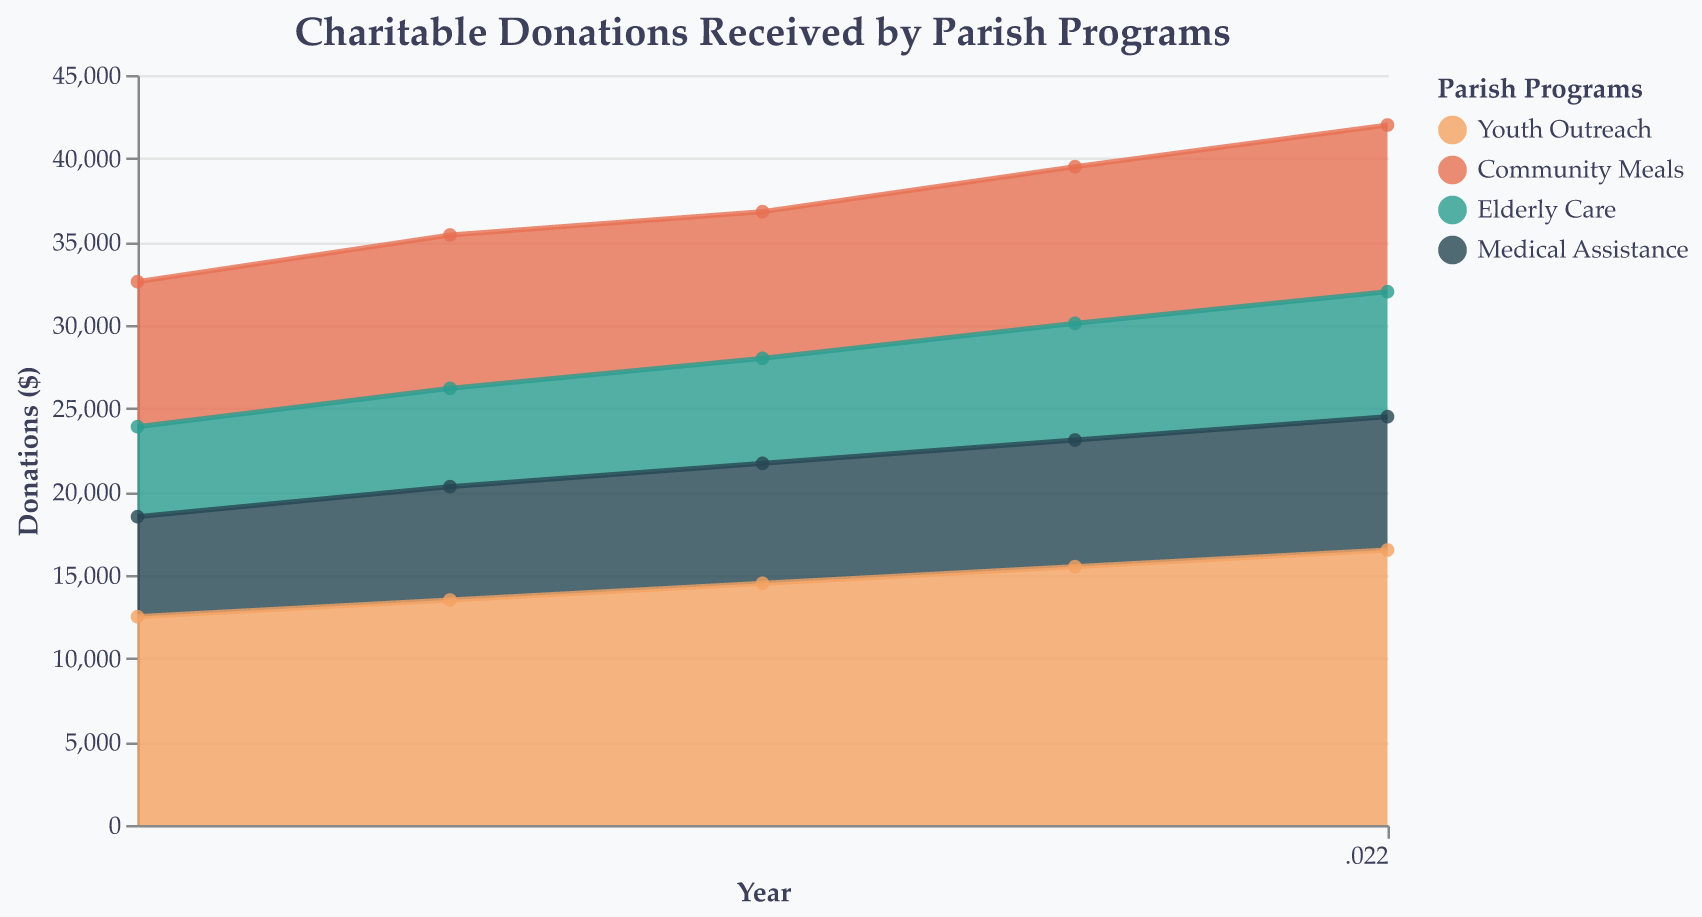What is the title of the chart? The title of the chart is located at the top and usually describes the content or purpose of the figure. In this case, the title is displayed prominently at the top.
Answer: Charitable Donations Received by Parish Programs How many parish programs are tracked in the figure? The legend on the right side of the chart shows the different parish programs tracked.
Answer: Four Which program received the highest donations in 2022? Look for the highest point in the area for each program in the year 2022 at the far right of the chart.
Answer: Youth Outreach What was the total amount donated to all programs in 2018? Add the charitable donations received by all programs in 2018. 12500 (Youth Outreach) + 8700 (Community Meals) + 5400 (Elderly Care) + 6000 (Medical Assistance).
Answer: 32,600 Between which years did Community Meals see the largest increase in charitable donations? Check the points and areas for Community Meals in each year and calculate the differences.
Answer: 2021 to 2022 How much did donations to Elderly Care increase from 2018 to 2022? Subtract the 2018 donations for Elderly Care from the 2022 donations: 7500 (2022) - 5400 (2018).
Answer: 2100 Which program witnessed the least variability in donations over the years? Compare the area heights for each program from 2018 to 2022; the program with the smallest differences in area heights has the least variability.
Answer: Medical Assistance What is the trend for Youth Outreach donations over the five years displayed? Observe the area corresponding to Youth Outreach from 2018 to 2022; the trend can be seen as an increase or decrease.
Answer: Increasing By how much did the total donations increase from 2018 to 2022? Compare the total donations from both years. Calculate 32,600 (2018) and 42,000 (2022), then find the difference.
Answer: 9,400 In which year did Medical Assistance see the highest donations? Look for the highest area point for Medical Assistance from 2018 to 2022.
Answer: 2022 